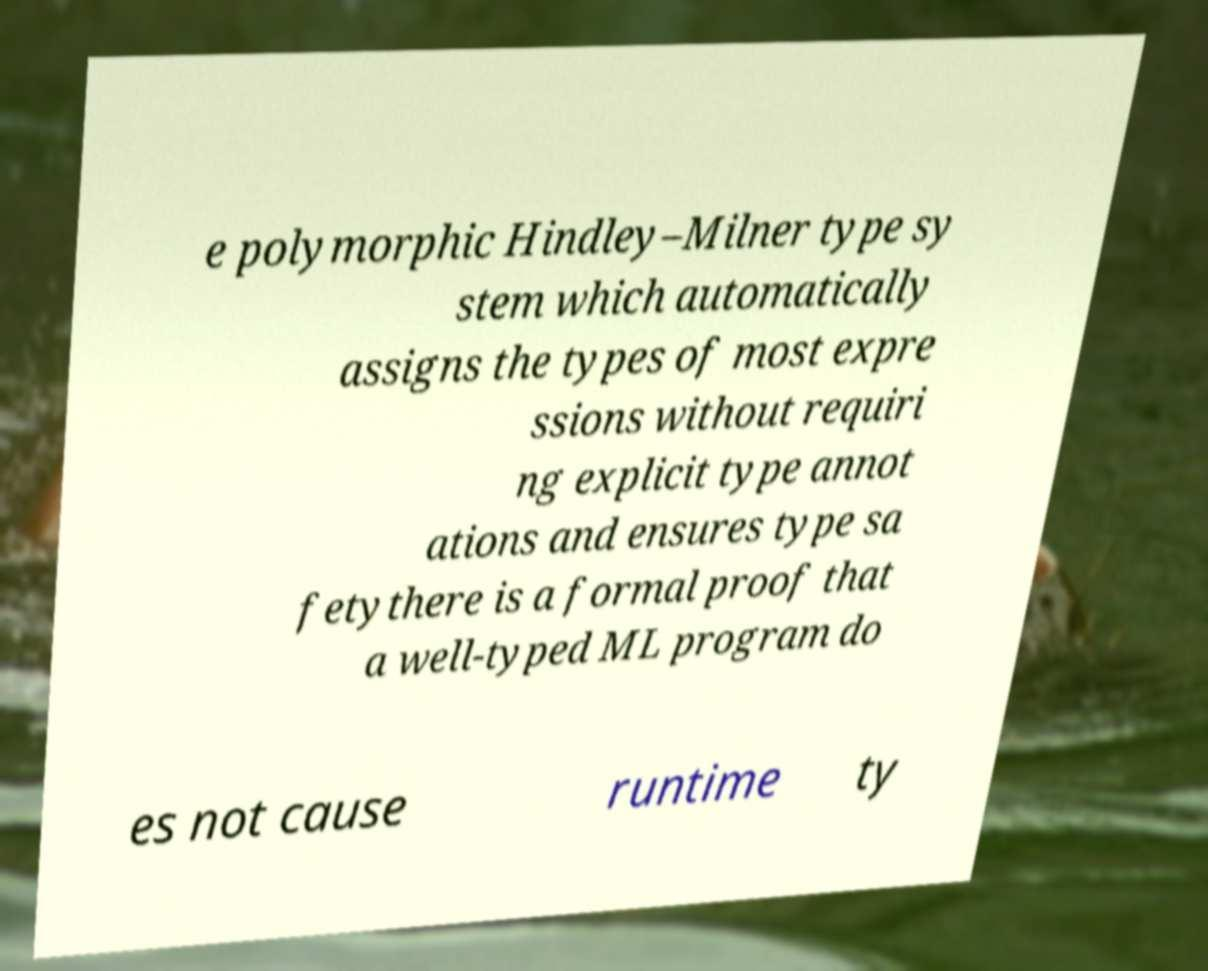Could you assist in decoding the text presented in this image and type it out clearly? e polymorphic Hindley–Milner type sy stem which automatically assigns the types of most expre ssions without requiri ng explicit type annot ations and ensures type sa fetythere is a formal proof that a well-typed ML program do es not cause runtime ty 